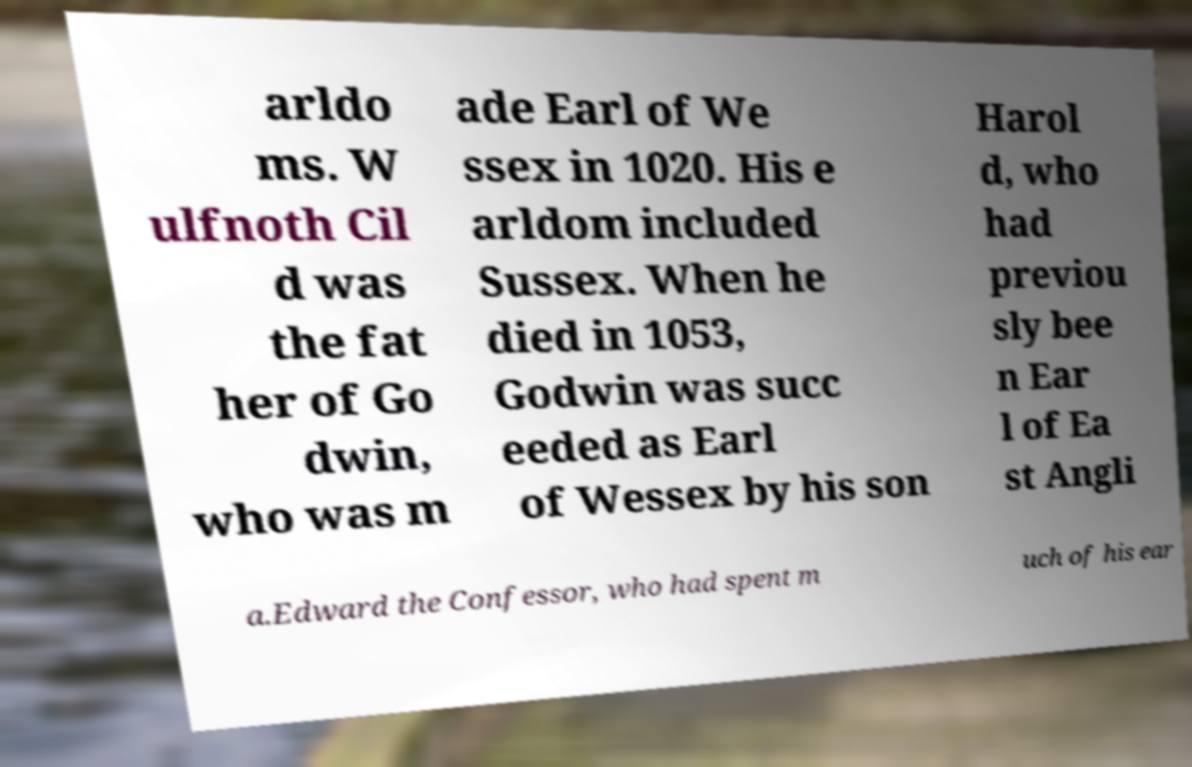Can you read and provide the text displayed in the image?This photo seems to have some interesting text. Can you extract and type it out for me? arldo ms. W ulfnoth Cil d was the fat her of Go dwin, who was m ade Earl of We ssex in 1020. His e arldom included Sussex. When he died in 1053, Godwin was succ eeded as Earl of Wessex by his son Harol d, who had previou sly bee n Ear l of Ea st Angli a.Edward the Confessor, who had spent m uch of his ear 